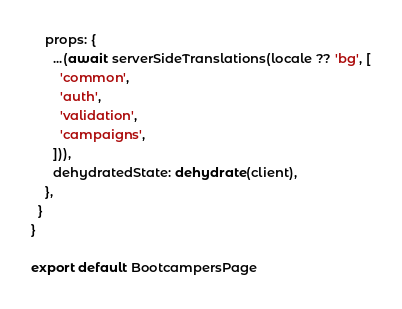<code> <loc_0><loc_0><loc_500><loc_500><_TypeScript_>    props: {
      ...(await serverSideTranslations(locale ?? 'bg', [
        'common',
        'auth',
        'validation',
        'campaigns',
      ])),
      dehydratedState: dehydrate(client),
    },
  }
}

export default BootcampersPage
</code> 